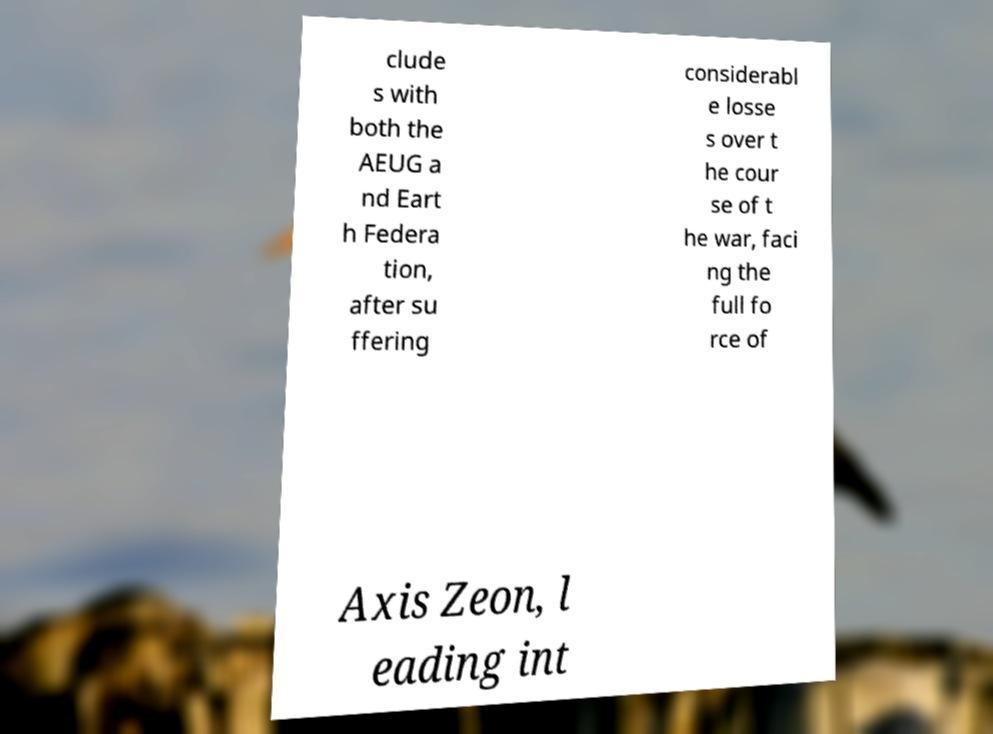Please read and relay the text visible in this image. What does it say? clude s with both the AEUG a nd Eart h Federa tion, after su ffering considerabl e losse s over t he cour se of t he war, faci ng the full fo rce of Axis Zeon, l eading int 